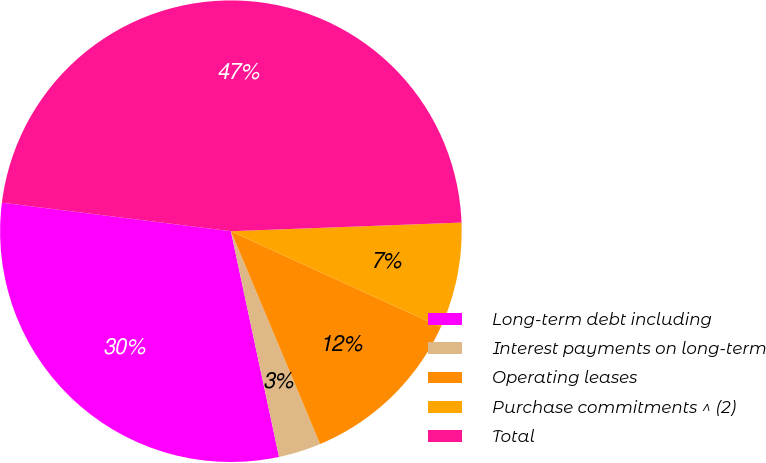Convert chart. <chart><loc_0><loc_0><loc_500><loc_500><pie_chart><fcel>Long-term debt including<fcel>Interest payments on long-term<fcel>Operating leases<fcel>Purchase commitments ^ (2)<fcel>Total<nl><fcel>30.32%<fcel>2.97%<fcel>11.86%<fcel>7.42%<fcel>47.43%<nl></chart> 